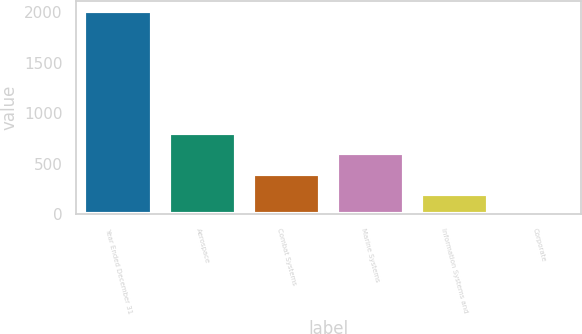Convert chart. <chart><loc_0><loc_0><loc_500><loc_500><bar_chart><fcel>Year Ended December 31<fcel>Aerospace<fcel>Combat Systems<fcel>Marine Systems<fcel>Information Systems and<fcel>Corporate<nl><fcel>2013<fcel>805.8<fcel>403.4<fcel>604.6<fcel>202.2<fcel>1<nl></chart> 